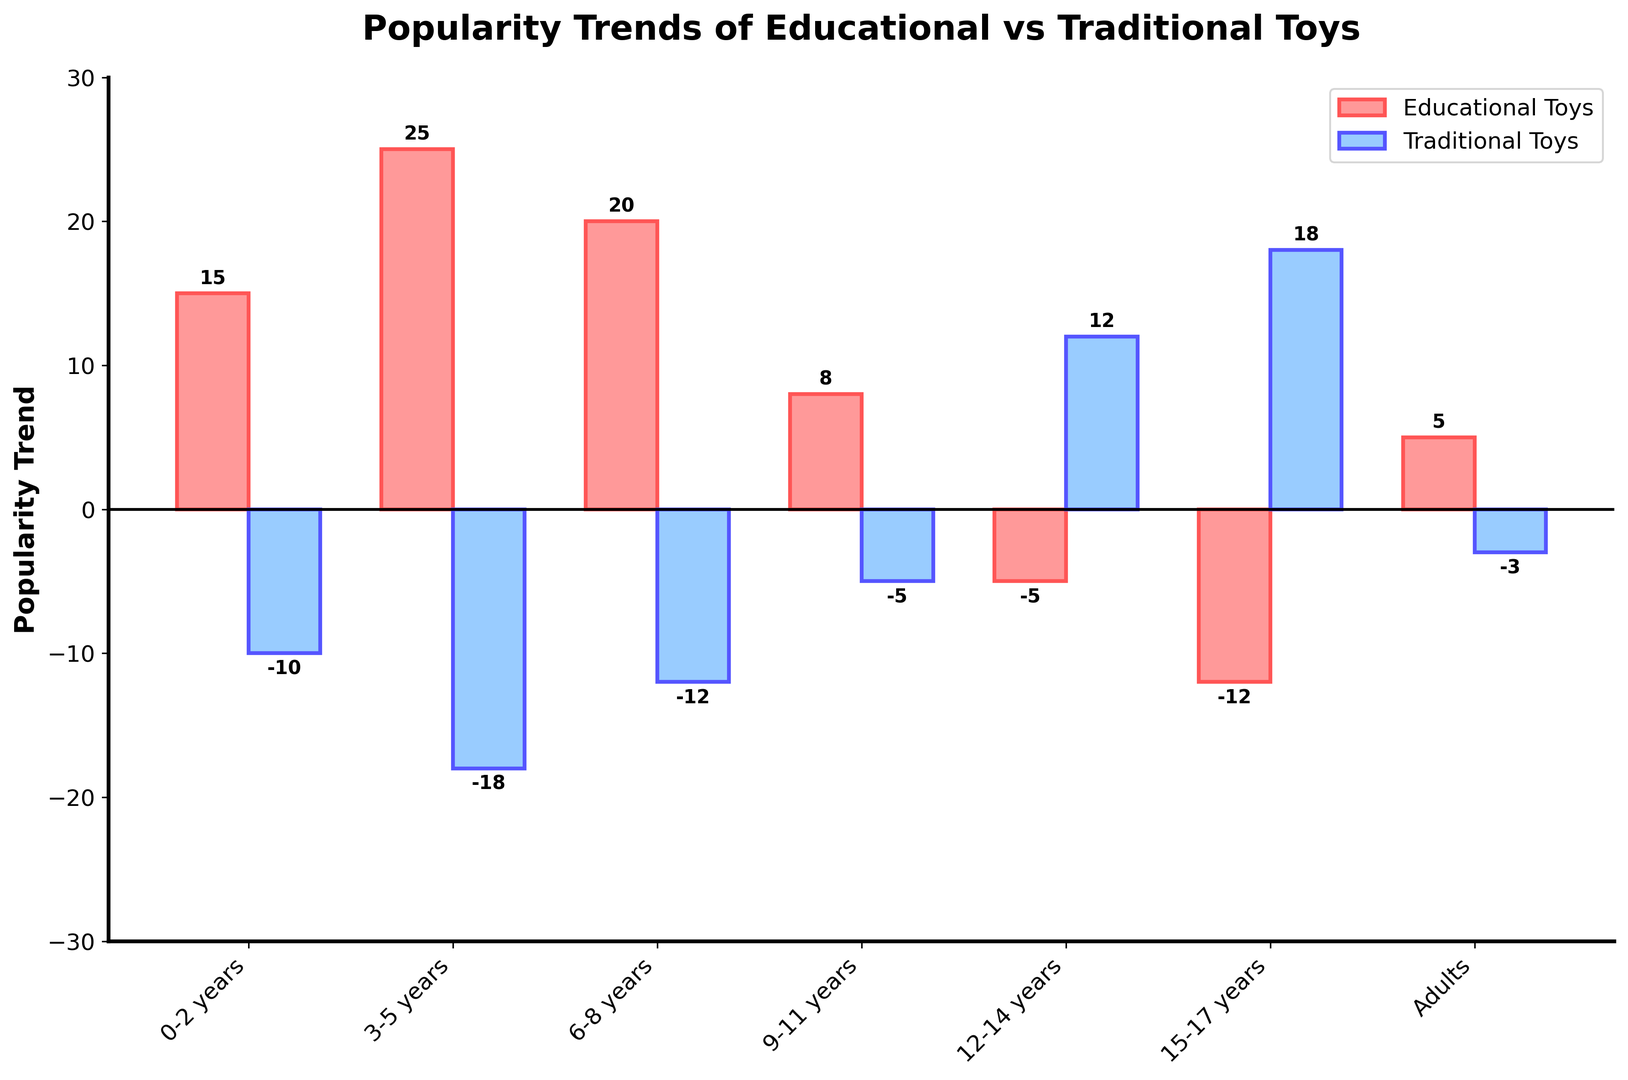What is the most popular toy type for children aged 3-5 years? The height of the bars for children aged 3-5 years indicates the popularity trend for both educational and traditional toys. The educational toy bar is significantly taller than the traditional toy bar.
Answer: Educational Toys Which toy type is more popular among children aged 6-8 years? The educational toy bar is taller for the 6-8 years age group, indicating a higher popularity compared to the traditional toy bar.
Answer: Educational Toys How does the popularity trend of traditional toys change as children grow older from aged 12-14 years to aged 15-17 years? The height of the traditional toy bars increases from the positive value for children aged 12-14 years to an even higher positive value for children aged 15-17 years.
Answer: It increases What is the sum of the popularity trends for educational and traditional toys for the 0-2 years age group? The values to add are 15 (educational toys) and -10 (traditional toys). 15 + (-10) = 5.
Answer: 5 What age group has the most negative popularity trend for educational toys? The lowest point on the educational toy bars is for the age group 15-17 years, which is -12.
Answer: 15-17 years Compare the popularity trend of educational toys for children aged 9-11 years versus traditional toys for children aged 15-17 years. Which one is higher? The value for educational toys for children aged 9-11 years is 8, while for traditional toys for children aged 15-17 years, it is 18. 18 is greater than 8.
Answer: Traditional Toys Are educational toys more popular than traditional toys for adults? The educational toy bar has a positive value (5) and the traditional toy bar has a negative value (-3) for adults, indicating greater popularity for educational toys.
Answer: Yes What is the average popularity trend of educational toys across all age groups? The values to average are 15, 25, 20, 8, -5, -12, and 5. (15 + 25 + 20 + 8 - 5 - 12 + 5) / 7 = 56 / 7 = 8
Answer: 8 Between the age groups 6-8 years and 9-11 years, in which age group are traditional toys more popular, and by how much? Traditional toys for age group 6-8 years have a value of -12, and for the age group 9-11 years, the value is -5. -5 is higher (less negative) than -12. Difference: -5 - (-12) = 7.
Answer: 9-11 years by 7 What is the difference in the popularity trend of traditional toys between the oldest (Adults) and youngest (0-2 years) age groups? The popularity trend for traditional toys for adults is -3 and for the 0-2 years age group is -10. -3 - (-10) = 7.
Answer: 7 